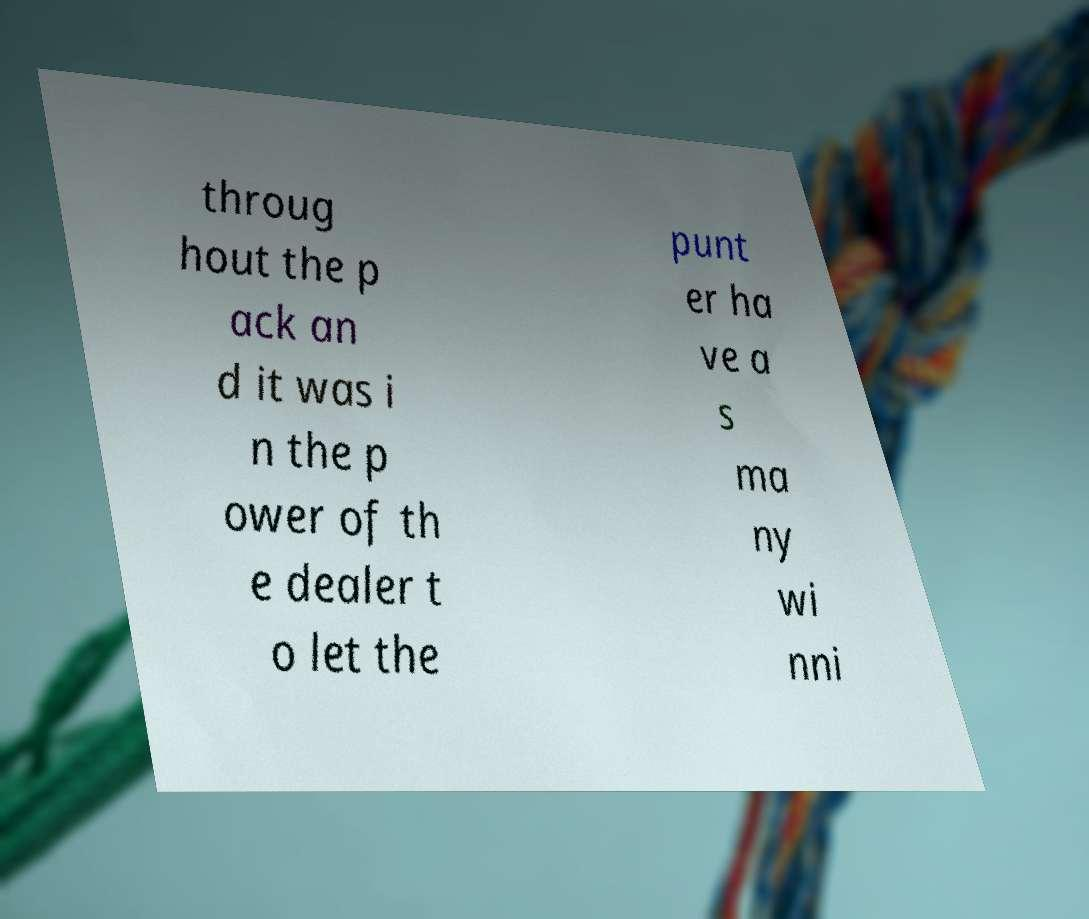Can you read and provide the text displayed in the image?This photo seems to have some interesting text. Can you extract and type it out for me? throug hout the p ack an d it was i n the p ower of th e dealer t o let the punt er ha ve a s ma ny wi nni 